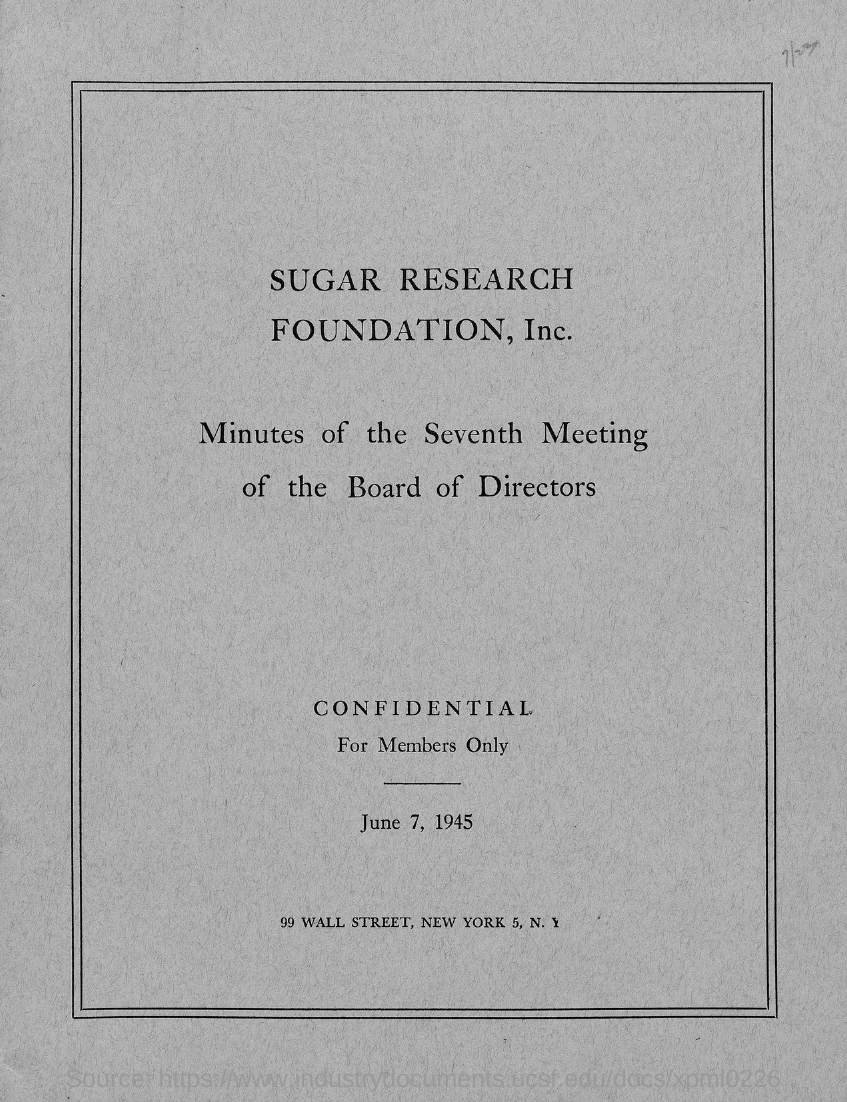List a handful of essential elements in this visual. The year mentioned in the given page is 1945. The street mentioned in the given page is named Wall Street. The month mentioned in the given page is June. The Sugar Research Foundation, Inc. is named in the given page. 